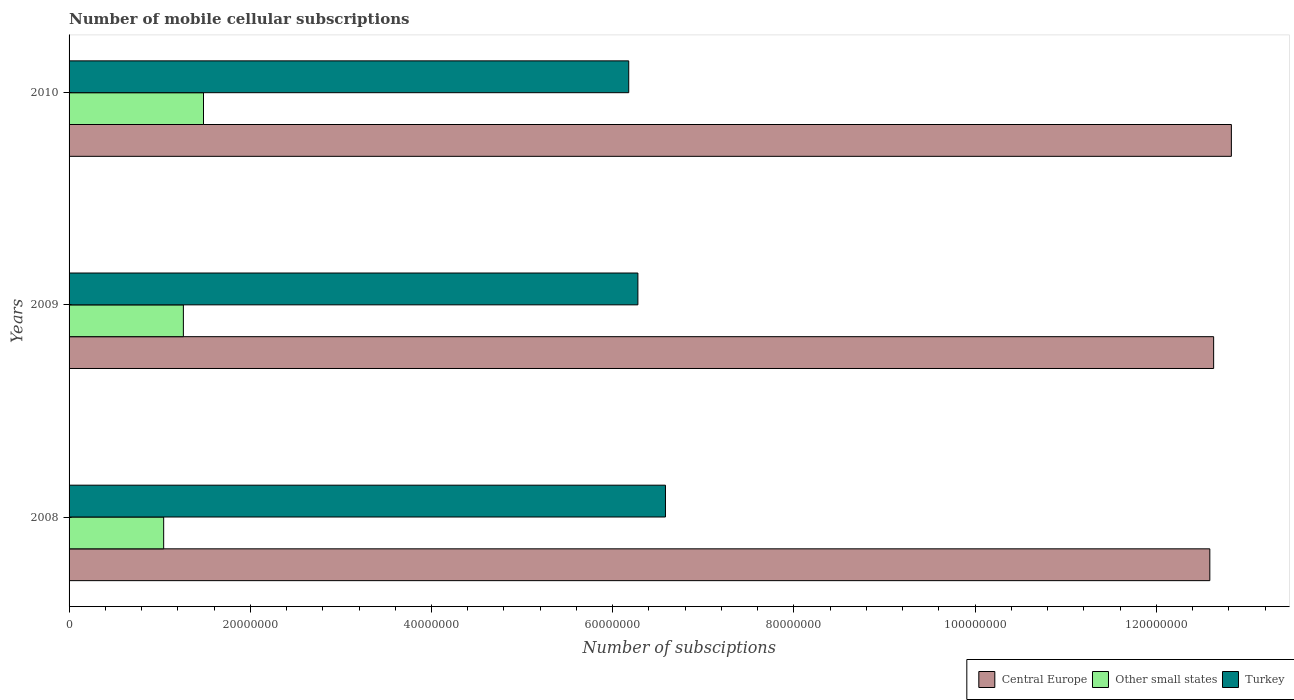How many groups of bars are there?
Ensure brevity in your answer.  3. Are the number of bars per tick equal to the number of legend labels?
Offer a terse response. Yes. How many bars are there on the 2nd tick from the top?
Your answer should be compact. 3. How many bars are there on the 1st tick from the bottom?
Make the answer very short. 3. In how many cases, is the number of bars for a given year not equal to the number of legend labels?
Offer a very short reply. 0. What is the number of mobile cellular subscriptions in Central Europe in 2008?
Make the answer very short. 1.26e+08. Across all years, what is the maximum number of mobile cellular subscriptions in Central Europe?
Give a very brief answer. 1.28e+08. Across all years, what is the minimum number of mobile cellular subscriptions in Other small states?
Ensure brevity in your answer.  1.04e+07. In which year was the number of mobile cellular subscriptions in Central Europe maximum?
Your answer should be compact. 2010. In which year was the number of mobile cellular subscriptions in Central Europe minimum?
Offer a very short reply. 2008. What is the total number of mobile cellular subscriptions in Central Europe in the graph?
Provide a succinct answer. 3.81e+08. What is the difference between the number of mobile cellular subscriptions in Central Europe in 2008 and that in 2010?
Provide a succinct answer. -2.38e+06. What is the difference between the number of mobile cellular subscriptions in Central Europe in 2010 and the number of mobile cellular subscriptions in Turkey in 2009?
Ensure brevity in your answer.  6.55e+07. What is the average number of mobile cellular subscriptions in Central Europe per year?
Offer a very short reply. 1.27e+08. In the year 2008, what is the difference between the number of mobile cellular subscriptions in Other small states and number of mobile cellular subscriptions in Turkey?
Give a very brief answer. -5.54e+07. In how many years, is the number of mobile cellular subscriptions in Turkey greater than 40000000 ?
Provide a short and direct response. 3. What is the ratio of the number of mobile cellular subscriptions in Central Europe in 2008 to that in 2010?
Keep it short and to the point. 0.98. Is the difference between the number of mobile cellular subscriptions in Other small states in 2008 and 2010 greater than the difference between the number of mobile cellular subscriptions in Turkey in 2008 and 2010?
Give a very brief answer. No. What is the difference between the highest and the second highest number of mobile cellular subscriptions in Central Europe?
Your answer should be very brief. 1.96e+06. What is the difference between the highest and the lowest number of mobile cellular subscriptions in Central Europe?
Your response must be concise. 2.38e+06. In how many years, is the number of mobile cellular subscriptions in Turkey greater than the average number of mobile cellular subscriptions in Turkey taken over all years?
Offer a terse response. 1. Is the sum of the number of mobile cellular subscriptions in Central Europe in 2009 and 2010 greater than the maximum number of mobile cellular subscriptions in Turkey across all years?
Offer a terse response. Yes. What does the 3rd bar from the top in 2010 represents?
Keep it short and to the point. Central Europe. What does the 1st bar from the bottom in 2010 represents?
Make the answer very short. Central Europe. Is it the case that in every year, the sum of the number of mobile cellular subscriptions in Turkey and number of mobile cellular subscriptions in Central Europe is greater than the number of mobile cellular subscriptions in Other small states?
Give a very brief answer. Yes. How many years are there in the graph?
Keep it short and to the point. 3. Does the graph contain any zero values?
Give a very brief answer. No. Where does the legend appear in the graph?
Your response must be concise. Bottom right. How many legend labels are there?
Give a very brief answer. 3. How are the legend labels stacked?
Your answer should be very brief. Horizontal. What is the title of the graph?
Provide a succinct answer. Number of mobile cellular subscriptions. What is the label or title of the X-axis?
Your answer should be very brief. Number of subsciptions. What is the Number of subsciptions of Central Europe in 2008?
Provide a succinct answer. 1.26e+08. What is the Number of subsciptions in Other small states in 2008?
Offer a terse response. 1.04e+07. What is the Number of subsciptions in Turkey in 2008?
Your answer should be compact. 6.58e+07. What is the Number of subsciptions of Central Europe in 2009?
Make the answer very short. 1.26e+08. What is the Number of subsciptions in Other small states in 2009?
Make the answer very short. 1.26e+07. What is the Number of subsciptions of Turkey in 2009?
Provide a short and direct response. 6.28e+07. What is the Number of subsciptions in Central Europe in 2010?
Make the answer very short. 1.28e+08. What is the Number of subsciptions of Other small states in 2010?
Your answer should be very brief. 1.48e+07. What is the Number of subsciptions in Turkey in 2010?
Keep it short and to the point. 6.18e+07. Across all years, what is the maximum Number of subsciptions in Central Europe?
Offer a very short reply. 1.28e+08. Across all years, what is the maximum Number of subsciptions in Other small states?
Your answer should be compact. 1.48e+07. Across all years, what is the maximum Number of subsciptions of Turkey?
Make the answer very short. 6.58e+07. Across all years, what is the minimum Number of subsciptions of Central Europe?
Your answer should be very brief. 1.26e+08. Across all years, what is the minimum Number of subsciptions in Other small states?
Your answer should be compact. 1.04e+07. Across all years, what is the minimum Number of subsciptions of Turkey?
Keep it short and to the point. 6.18e+07. What is the total Number of subsciptions in Central Europe in the graph?
Offer a terse response. 3.81e+08. What is the total Number of subsciptions of Other small states in the graph?
Make the answer very short. 3.79e+07. What is the total Number of subsciptions of Turkey in the graph?
Provide a succinct answer. 1.90e+08. What is the difference between the Number of subsciptions in Central Europe in 2008 and that in 2009?
Your response must be concise. -4.20e+05. What is the difference between the Number of subsciptions in Other small states in 2008 and that in 2009?
Your answer should be very brief. -2.18e+06. What is the difference between the Number of subsciptions of Turkey in 2008 and that in 2009?
Your answer should be very brief. 3.04e+06. What is the difference between the Number of subsciptions in Central Europe in 2008 and that in 2010?
Make the answer very short. -2.38e+06. What is the difference between the Number of subsciptions of Other small states in 2008 and that in 2010?
Offer a terse response. -4.40e+06. What is the difference between the Number of subsciptions in Turkey in 2008 and that in 2010?
Offer a terse response. 4.05e+06. What is the difference between the Number of subsciptions of Central Europe in 2009 and that in 2010?
Provide a succinct answer. -1.96e+06. What is the difference between the Number of subsciptions in Other small states in 2009 and that in 2010?
Offer a very short reply. -2.22e+06. What is the difference between the Number of subsciptions of Turkey in 2009 and that in 2010?
Offer a terse response. 1.01e+06. What is the difference between the Number of subsciptions in Central Europe in 2008 and the Number of subsciptions in Other small states in 2009?
Provide a succinct answer. 1.13e+08. What is the difference between the Number of subsciptions in Central Europe in 2008 and the Number of subsciptions in Turkey in 2009?
Provide a succinct answer. 6.31e+07. What is the difference between the Number of subsciptions of Other small states in 2008 and the Number of subsciptions of Turkey in 2009?
Provide a succinct answer. -5.23e+07. What is the difference between the Number of subsciptions in Central Europe in 2008 and the Number of subsciptions in Other small states in 2010?
Ensure brevity in your answer.  1.11e+08. What is the difference between the Number of subsciptions of Central Europe in 2008 and the Number of subsciptions of Turkey in 2010?
Make the answer very short. 6.41e+07. What is the difference between the Number of subsciptions in Other small states in 2008 and the Number of subsciptions in Turkey in 2010?
Your answer should be very brief. -5.13e+07. What is the difference between the Number of subsciptions in Central Europe in 2009 and the Number of subsciptions in Other small states in 2010?
Provide a succinct answer. 1.11e+08. What is the difference between the Number of subsciptions in Central Europe in 2009 and the Number of subsciptions in Turkey in 2010?
Offer a terse response. 6.46e+07. What is the difference between the Number of subsciptions in Other small states in 2009 and the Number of subsciptions in Turkey in 2010?
Your response must be concise. -4.92e+07. What is the average Number of subsciptions of Central Europe per year?
Offer a very short reply. 1.27e+08. What is the average Number of subsciptions of Other small states per year?
Keep it short and to the point. 1.26e+07. What is the average Number of subsciptions in Turkey per year?
Provide a succinct answer. 6.35e+07. In the year 2008, what is the difference between the Number of subsciptions in Central Europe and Number of subsciptions in Other small states?
Keep it short and to the point. 1.15e+08. In the year 2008, what is the difference between the Number of subsciptions in Central Europe and Number of subsciptions in Turkey?
Your answer should be very brief. 6.01e+07. In the year 2008, what is the difference between the Number of subsciptions in Other small states and Number of subsciptions in Turkey?
Your response must be concise. -5.54e+07. In the year 2009, what is the difference between the Number of subsciptions of Central Europe and Number of subsciptions of Other small states?
Give a very brief answer. 1.14e+08. In the year 2009, what is the difference between the Number of subsciptions in Central Europe and Number of subsciptions in Turkey?
Ensure brevity in your answer.  6.35e+07. In the year 2009, what is the difference between the Number of subsciptions of Other small states and Number of subsciptions of Turkey?
Your answer should be compact. -5.02e+07. In the year 2010, what is the difference between the Number of subsciptions of Central Europe and Number of subsciptions of Other small states?
Ensure brevity in your answer.  1.13e+08. In the year 2010, what is the difference between the Number of subsciptions of Central Europe and Number of subsciptions of Turkey?
Provide a short and direct response. 6.65e+07. In the year 2010, what is the difference between the Number of subsciptions in Other small states and Number of subsciptions in Turkey?
Offer a very short reply. -4.69e+07. What is the ratio of the Number of subsciptions of Other small states in 2008 to that in 2009?
Your answer should be compact. 0.83. What is the ratio of the Number of subsciptions of Turkey in 2008 to that in 2009?
Offer a terse response. 1.05. What is the ratio of the Number of subsciptions in Central Europe in 2008 to that in 2010?
Keep it short and to the point. 0.98. What is the ratio of the Number of subsciptions in Other small states in 2008 to that in 2010?
Make the answer very short. 0.7. What is the ratio of the Number of subsciptions in Turkey in 2008 to that in 2010?
Provide a succinct answer. 1.07. What is the ratio of the Number of subsciptions in Central Europe in 2009 to that in 2010?
Offer a terse response. 0.98. What is the ratio of the Number of subsciptions in Other small states in 2009 to that in 2010?
Provide a succinct answer. 0.85. What is the ratio of the Number of subsciptions in Turkey in 2009 to that in 2010?
Your answer should be compact. 1.02. What is the difference between the highest and the second highest Number of subsciptions in Central Europe?
Make the answer very short. 1.96e+06. What is the difference between the highest and the second highest Number of subsciptions of Other small states?
Offer a terse response. 2.22e+06. What is the difference between the highest and the second highest Number of subsciptions in Turkey?
Your answer should be very brief. 3.04e+06. What is the difference between the highest and the lowest Number of subsciptions in Central Europe?
Your response must be concise. 2.38e+06. What is the difference between the highest and the lowest Number of subsciptions of Other small states?
Offer a very short reply. 4.40e+06. What is the difference between the highest and the lowest Number of subsciptions in Turkey?
Ensure brevity in your answer.  4.05e+06. 